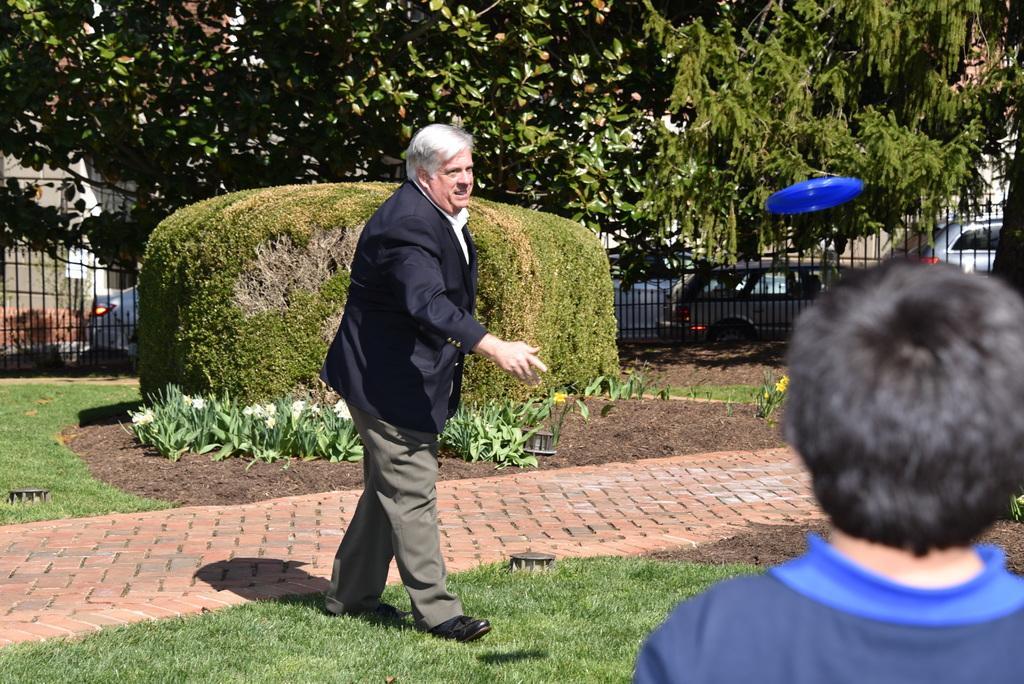Can you describe this image briefly? In the foreground I can see two persons on the ground. In the background I can see plants, fence, disc, trees and fleets of cars on the road. This image is taken in a park. 